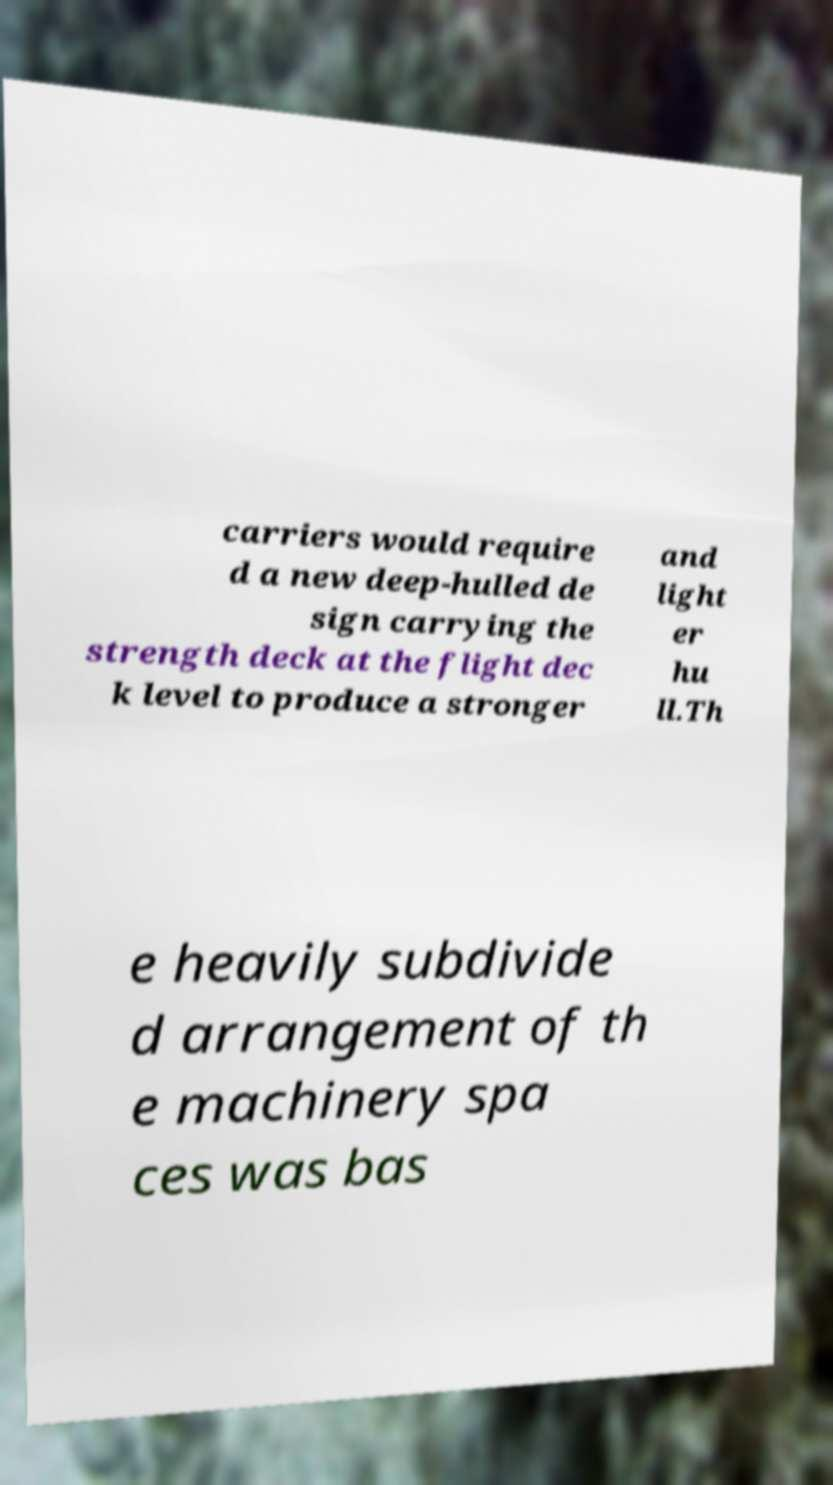Could you extract and type out the text from this image? carriers would require d a new deep-hulled de sign carrying the strength deck at the flight dec k level to produce a stronger and light er hu ll.Th e heavily subdivide d arrangement of th e machinery spa ces was bas 